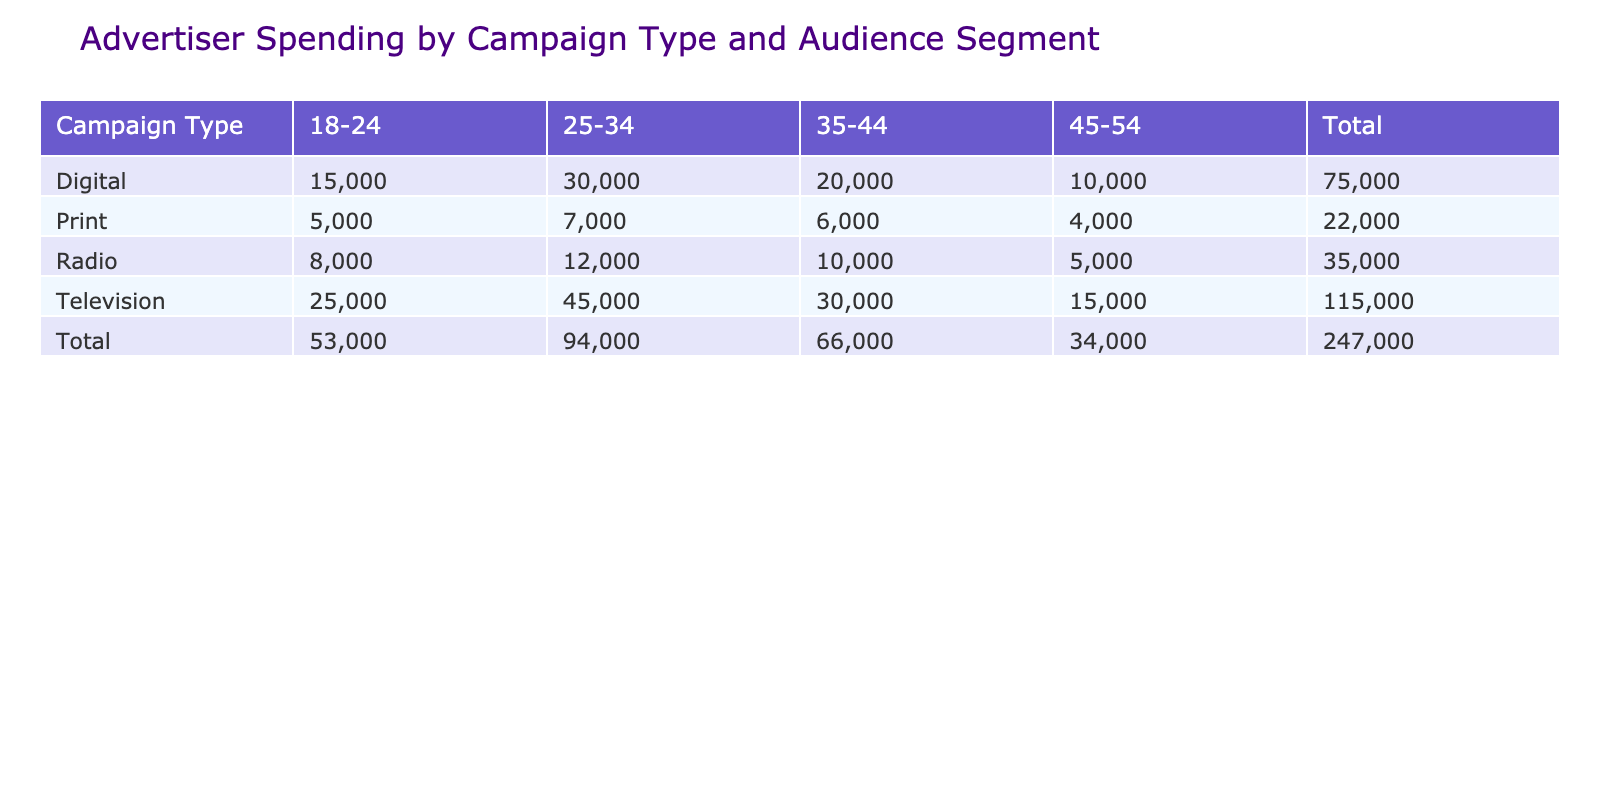What is the total advertiser spending for the Television campaign type? Looking at the table, I can find the row for Television and then sum the values across all audience segments: 25000 + 45000 + 30000 + 15000 = 115000.
Answer: 115000 Which audience segment had the highest spending in Digital campaigns? In the Digital row, I will compare the spending amounts across the audience segments. The spending values are 15000, 30000, 20000, and 10000 for the 18-24, 25-34, 35-44, and 45-54 segments respectively. The highest is 30000 from the 25-34 segment.
Answer: 25-34 Is the total spending for the Radio campaign type higher than for Print? First, I calculate the total for Radio: 8000 + 12000 + 10000 + 5000 = 35000, and for Print: 5000 + 7000 + 6000 + 4000 = 22000. Since 35000 is greater than 22000, the answer is yes.
Answer: Yes What is the average spending across all audience segments for campaign types aimed at 35-44? For the 35-44 audience segment, I take the spending from all campaign types: 20000 (Digital) + 30000 (Television) + 10000 (Radio) + 6000 (Print) = 66000. Then I divide that by 4 (the number of campaign types) to get the average: 66000 / 4 = 16500.
Answer: 16500 Which campaign type has the lowest total spending? I need to calculate the total spending for each campaign type: Digital: 15000 + 30000 + 20000 + 10000 = 75000, Television: 115000 (calculated above), Radio: 35000, and Print: 22000. The lowest total is for Print.
Answer: Print What is the spending difference between the audience segments 25-34 and 45-54 for the Television campaign type? For Television, the spending for 25-34 is 45000 and for 45-54 is 15000. The difference is calculated by subtracting: 45000 - 15000 = 30000.
Answer: 30000 Is the spending for Digital campaigns for the 45-54 segment greater than the Radio campaigns for the same segment? Digital spending for 45-54 is 10000, while Radio spending for the same segment is 5000. Comparing these values, 10000 is greater than 5000, so the answer is yes.
Answer: Yes What is the total advertiser spending across all campaign types for the 18-24 audience segment? I will sum the spending for each campaign type for the 18-24 audience segment: 15000 (Digital) + 25000 (Television) + 8000 (Radio) + 5000 (Print) = 53000.
Answer: 53000 What is the maximum spending among any audience segment across all campaign types? I will check the spending values across all campaign types and segments: 15000 (Digital 18-24), 30000 (Digital 25-34), 20000 (Digital 35-44), 10000 (Digital 45-54), 25000 (Television 18-24), 45000 (Television 25-34), 30000 (Television 35-44), 15000 (Television 45-54), 8000 (Radio 18-24), 12000 (Radio 25-34), 10000 (Radio 35-44), 5000 (Radio 45-54), 5000 (Print 18-24), 7000 (Print 25-34), 6000 (Print 35-44), and 4000 (Print 45-54). The maximum value is 45000 from the Television 25-34 segment.
Answer: 45000 